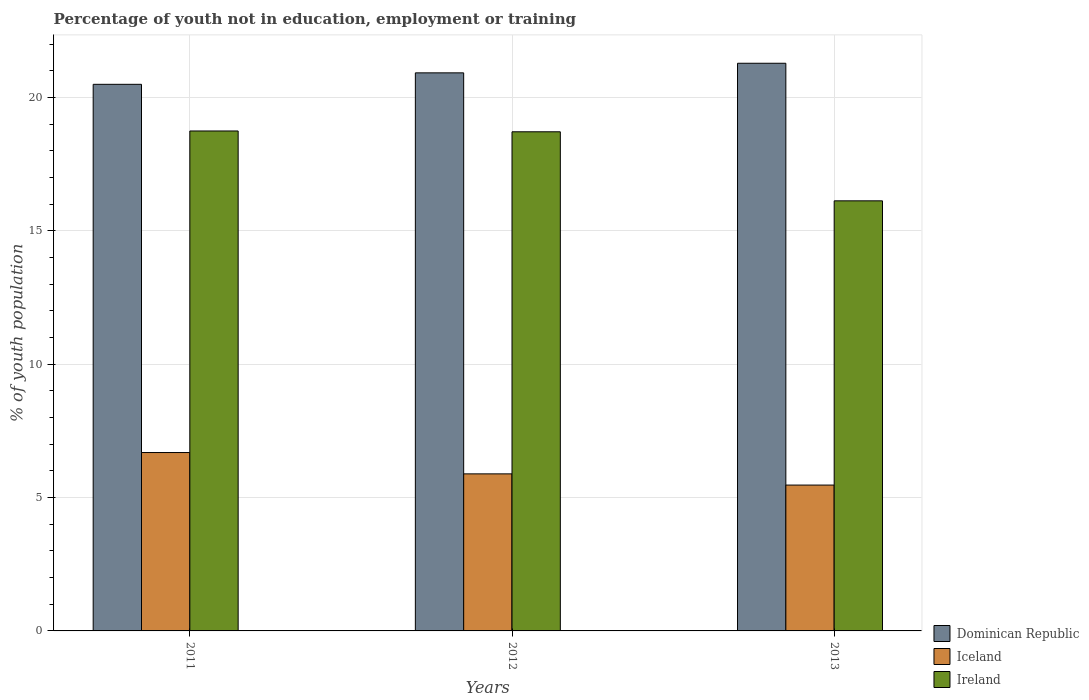How many groups of bars are there?
Give a very brief answer. 3. How many bars are there on the 3rd tick from the right?
Provide a succinct answer. 3. What is the label of the 2nd group of bars from the left?
Make the answer very short. 2012. What is the percentage of unemployed youth population in in Ireland in 2012?
Offer a terse response. 18.72. Across all years, what is the maximum percentage of unemployed youth population in in Ireland?
Ensure brevity in your answer.  18.75. In which year was the percentage of unemployed youth population in in Iceland maximum?
Your answer should be compact. 2011. What is the total percentage of unemployed youth population in in Ireland in the graph?
Offer a terse response. 53.6. What is the difference between the percentage of unemployed youth population in in Iceland in 2011 and that in 2012?
Keep it short and to the point. 0.8. What is the difference between the percentage of unemployed youth population in in Dominican Republic in 2011 and the percentage of unemployed youth population in in Ireland in 2012?
Keep it short and to the point. 1.78. What is the average percentage of unemployed youth population in in Iceland per year?
Provide a short and direct response. 6.02. In the year 2011, what is the difference between the percentage of unemployed youth population in in Ireland and percentage of unemployed youth population in in Iceland?
Offer a very short reply. 12.06. In how many years, is the percentage of unemployed youth population in in Ireland greater than 11 %?
Your answer should be compact. 3. What is the ratio of the percentage of unemployed youth population in in Dominican Republic in 2011 to that in 2012?
Ensure brevity in your answer.  0.98. Is the percentage of unemployed youth population in in Ireland in 2012 less than that in 2013?
Ensure brevity in your answer.  No. What is the difference between the highest and the second highest percentage of unemployed youth population in in Iceland?
Your answer should be compact. 0.8. What is the difference between the highest and the lowest percentage of unemployed youth population in in Ireland?
Keep it short and to the point. 2.62. In how many years, is the percentage of unemployed youth population in in Ireland greater than the average percentage of unemployed youth population in in Ireland taken over all years?
Your answer should be very brief. 2. Is the sum of the percentage of unemployed youth population in in Iceland in 2011 and 2012 greater than the maximum percentage of unemployed youth population in in Ireland across all years?
Keep it short and to the point. No. What does the 1st bar from the left in 2011 represents?
Make the answer very short. Dominican Republic. What does the 2nd bar from the right in 2011 represents?
Offer a terse response. Iceland. Is it the case that in every year, the sum of the percentage of unemployed youth population in in Dominican Republic and percentage of unemployed youth population in in Ireland is greater than the percentage of unemployed youth population in in Iceland?
Your response must be concise. Yes. How many bars are there?
Ensure brevity in your answer.  9. Where does the legend appear in the graph?
Provide a short and direct response. Bottom right. How many legend labels are there?
Provide a succinct answer. 3. What is the title of the graph?
Provide a succinct answer. Percentage of youth not in education, employment or training. Does "Europe(all income levels)" appear as one of the legend labels in the graph?
Your answer should be very brief. No. What is the label or title of the Y-axis?
Your answer should be compact. % of youth population. What is the % of youth population in Iceland in 2011?
Make the answer very short. 6.69. What is the % of youth population in Ireland in 2011?
Make the answer very short. 18.75. What is the % of youth population of Dominican Republic in 2012?
Keep it short and to the point. 20.93. What is the % of youth population in Iceland in 2012?
Offer a very short reply. 5.89. What is the % of youth population in Ireland in 2012?
Keep it short and to the point. 18.72. What is the % of youth population of Dominican Republic in 2013?
Your answer should be compact. 21.29. What is the % of youth population in Iceland in 2013?
Your response must be concise. 5.47. What is the % of youth population of Ireland in 2013?
Your response must be concise. 16.13. Across all years, what is the maximum % of youth population in Dominican Republic?
Your answer should be compact. 21.29. Across all years, what is the maximum % of youth population in Iceland?
Offer a very short reply. 6.69. Across all years, what is the maximum % of youth population of Ireland?
Your answer should be compact. 18.75. Across all years, what is the minimum % of youth population in Iceland?
Provide a succinct answer. 5.47. Across all years, what is the minimum % of youth population in Ireland?
Provide a succinct answer. 16.13. What is the total % of youth population in Dominican Republic in the graph?
Give a very brief answer. 62.72. What is the total % of youth population of Iceland in the graph?
Your response must be concise. 18.05. What is the total % of youth population of Ireland in the graph?
Provide a short and direct response. 53.6. What is the difference between the % of youth population in Dominican Republic in 2011 and that in 2012?
Offer a very short reply. -0.43. What is the difference between the % of youth population in Iceland in 2011 and that in 2012?
Your answer should be very brief. 0.8. What is the difference between the % of youth population of Dominican Republic in 2011 and that in 2013?
Keep it short and to the point. -0.79. What is the difference between the % of youth population in Iceland in 2011 and that in 2013?
Your answer should be compact. 1.22. What is the difference between the % of youth population of Ireland in 2011 and that in 2013?
Ensure brevity in your answer.  2.62. What is the difference between the % of youth population of Dominican Republic in 2012 and that in 2013?
Offer a terse response. -0.36. What is the difference between the % of youth population in Iceland in 2012 and that in 2013?
Your response must be concise. 0.42. What is the difference between the % of youth population in Ireland in 2012 and that in 2013?
Provide a succinct answer. 2.59. What is the difference between the % of youth population of Dominican Republic in 2011 and the % of youth population of Iceland in 2012?
Your answer should be very brief. 14.61. What is the difference between the % of youth population in Dominican Republic in 2011 and the % of youth population in Ireland in 2012?
Provide a short and direct response. 1.78. What is the difference between the % of youth population of Iceland in 2011 and the % of youth population of Ireland in 2012?
Offer a terse response. -12.03. What is the difference between the % of youth population in Dominican Republic in 2011 and the % of youth population in Iceland in 2013?
Offer a terse response. 15.03. What is the difference between the % of youth population of Dominican Republic in 2011 and the % of youth population of Ireland in 2013?
Your response must be concise. 4.37. What is the difference between the % of youth population in Iceland in 2011 and the % of youth population in Ireland in 2013?
Your answer should be very brief. -9.44. What is the difference between the % of youth population of Dominican Republic in 2012 and the % of youth population of Iceland in 2013?
Offer a terse response. 15.46. What is the difference between the % of youth population of Dominican Republic in 2012 and the % of youth population of Ireland in 2013?
Keep it short and to the point. 4.8. What is the difference between the % of youth population in Iceland in 2012 and the % of youth population in Ireland in 2013?
Provide a succinct answer. -10.24. What is the average % of youth population in Dominican Republic per year?
Your answer should be very brief. 20.91. What is the average % of youth population of Iceland per year?
Ensure brevity in your answer.  6.02. What is the average % of youth population of Ireland per year?
Provide a short and direct response. 17.87. In the year 2011, what is the difference between the % of youth population in Dominican Republic and % of youth population in Iceland?
Offer a very short reply. 13.81. In the year 2011, what is the difference between the % of youth population in Dominican Republic and % of youth population in Ireland?
Ensure brevity in your answer.  1.75. In the year 2011, what is the difference between the % of youth population of Iceland and % of youth population of Ireland?
Offer a terse response. -12.06. In the year 2012, what is the difference between the % of youth population of Dominican Republic and % of youth population of Iceland?
Make the answer very short. 15.04. In the year 2012, what is the difference between the % of youth population in Dominican Republic and % of youth population in Ireland?
Provide a short and direct response. 2.21. In the year 2012, what is the difference between the % of youth population in Iceland and % of youth population in Ireland?
Ensure brevity in your answer.  -12.83. In the year 2013, what is the difference between the % of youth population in Dominican Republic and % of youth population in Iceland?
Offer a very short reply. 15.82. In the year 2013, what is the difference between the % of youth population of Dominican Republic and % of youth population of Ireland?
Make the answer very short. 5.16. In the year 2013, what is the difference between the % of youth population of Iceland and % of youth population of Ireland?
Provide a succinct answer. -10.66. What is the ratio of the % of youth population of Dominican Republic in 2011 to that in 2012?
Provide a succinct answer. 0.98. What is the ratio of the % of youth population in Iceland in 2011 to that in 2012?
Give a very brief answer. 1.14. What is the ratio of the % of youth population in Ireland in 2011 to that in 2012?
Your answer should be very brief. 1. What is the ratio of the % of youth population of Dominican Republic in 2011 to that in 2013?
Keep it short and to the point. 0.96. What is the ratio of the % of youth population of Iceland in 2011 to that in 2013?
Offer a terse response. 1.22. What is the ratio of the % of youth population of Ireland in 2011 to that in 2013?
Your answer should be compact. 1.16. What is the ratio of the % of youth population of Dominican Republic in 2012 to that in 2013?
Provide a succinct answer. 0.98. What is the ratio of the % of youth population of Iceland in 2012 to that in 2013?
Provide a succinct answer. 1.08. What is the ratio of the % of youth population in Ireland in 2012 to that in 2013?
Provide a succinct answer. 1.16. What is the difference between the highest and the second highest % of youth population in Dominican Republic?
Offer a terse response. 0.36. What is the difference between the highest and the second highest % of youth population in Iceland?
Make the answer very short. 0.8. What is the difference between the highest and the lowest % of youth population of Dominican Republic?
Offer a terse response. 0.79. What is the difference between the highest and the lowest % of youth population of Iceland?
Ensure brevity in your answer.  1.22. What is the difference between the highest and the lowest % of youth population of Ireland?
Provide a succinct answer. 2.62. 